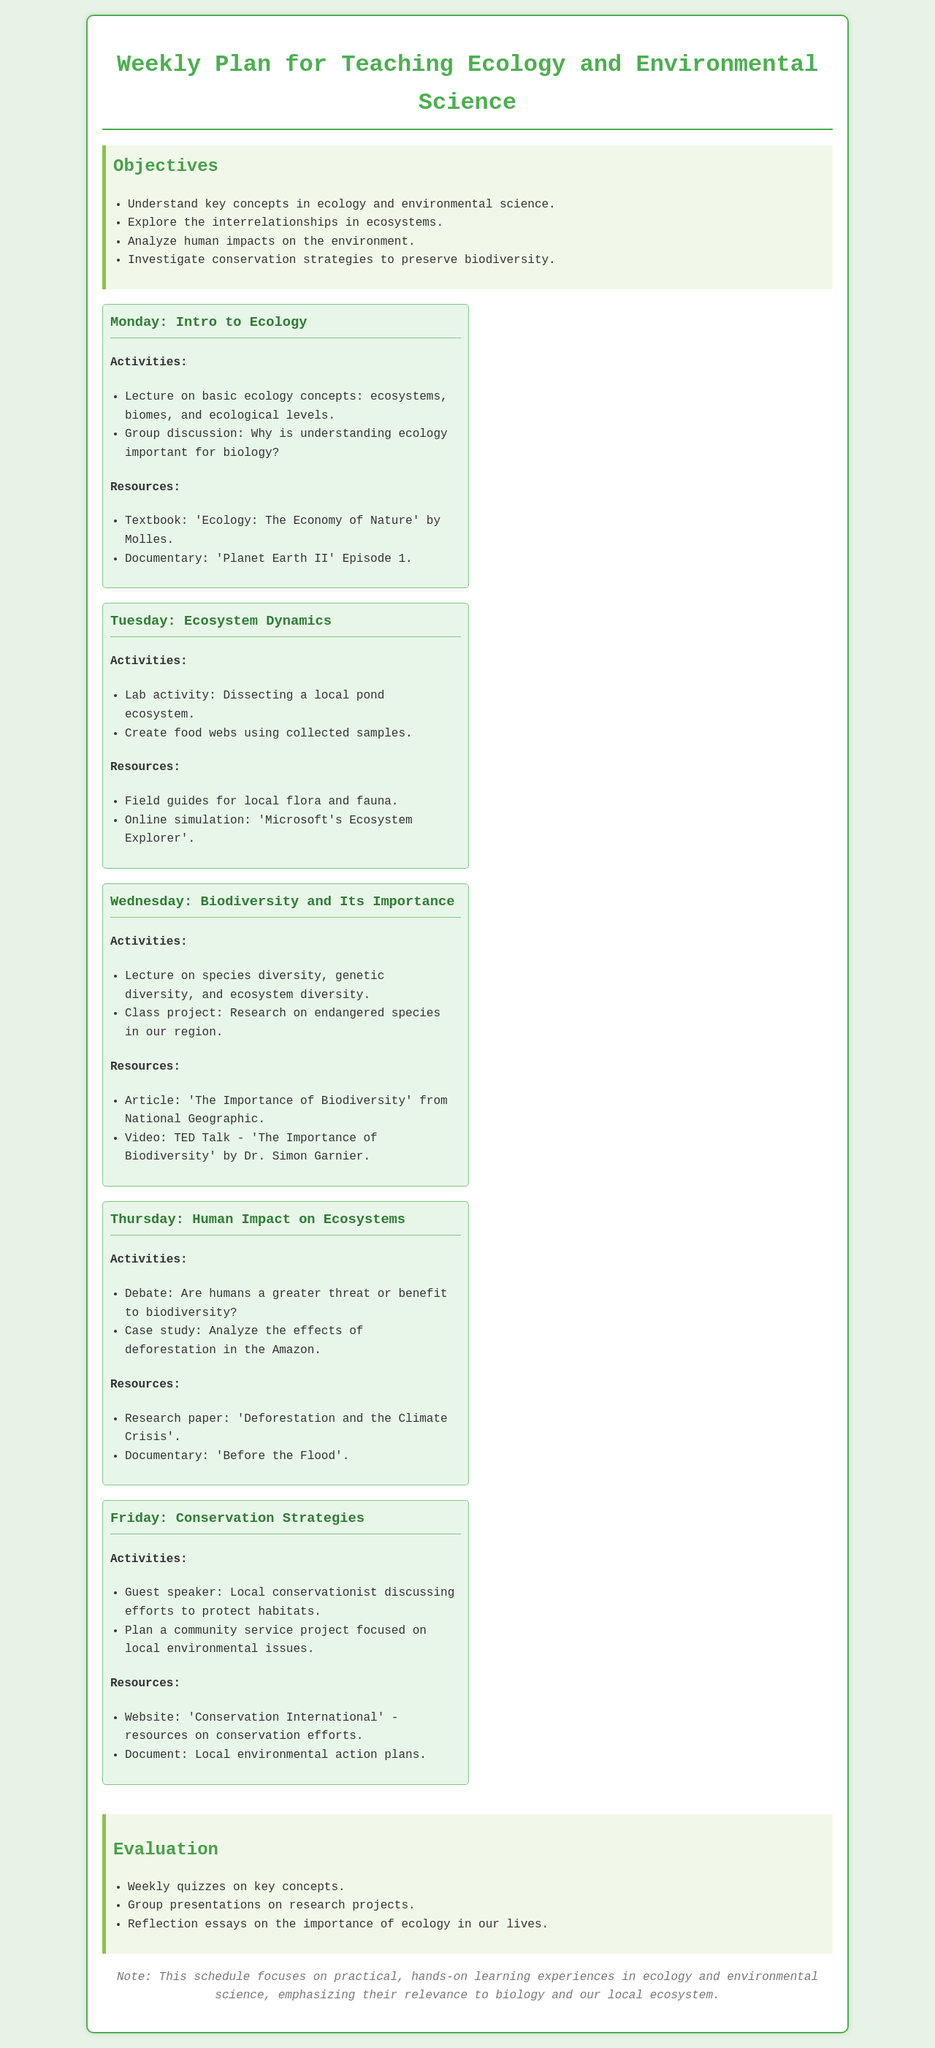What is the title of the document? The title of the document is specified in the header section, clearly indicating the content it covers.
Answer: Weekly Plan for Teaching Ecology and Environmental Science What is the main objective concerning biodiversity? The document lists key objectives, one of which focuses specifically on biodiversity and its preservation.
Answer: Investigate conservation strategies to preserve biodiversity What activity is planned for Tuesday? The scheduled activity for Tuesday highlights a hands-on approach to understanding ecosystem dynamics.
Answer: Lab activity: Dissecting a local pond ecosystem Who is the guest speaker on Friday? The document notes a special guest speaker scheduled for Friday's activities, emphasizing local ecological efforts.
Answer: Local conservationist What resource is used for the lecture on biodiversity? Resources for lessons are listed, including specific articles and videos, particularly for biodiversity lectures.
Answer: Article: 'The Importance of Biodiversity' from National Geographic What kind of evaluation method is mentioned? The evaluation section describes various methods of assessing student understanding and engagement throughout the week.
Answer: Weekly quizzes on key concepts What environmental issue is analyzed during the Thursday session? The Thursday activities include discussions and cases that examine significant ecological challenges facing our world.
Answer: Effects of deforestation in the Amazon How many days of activities are outlined in the schedule? The schedule breaks down educational activities across the weekdays, clearly showing the structure for the week.
Answer: Five days 